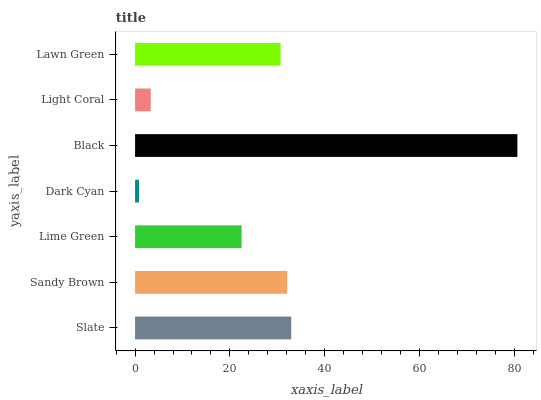Is Dark Cyan the minimum?
Answer yes or no. Yes. Is Black the maximum?
Answer yes or no. Yes. Is Sandy Brown the minimum?
Answer yes or no. No. Is Sandy Brown the maximum?
Answer yes or no. No. Is Slate greater than Sandy Brown?
Answer yes or no. Yes. Is Sandy Brown less than Slate?
Answer yes or no. Yes. Is Sandy Brown greater than Slate?
Answer yes or no. No. Is Slate less than Sandy Brown?
Answer yes or no. No. Is Lawn Green the high median?
Answer yes or no. Yes. Is Lawn Green the low median?
Answer yes or no. Yes. Is Sandy Brown the high median?
Answer yes or no. No. Is Sandy Brown the low median?
Answer yes or no. No. 